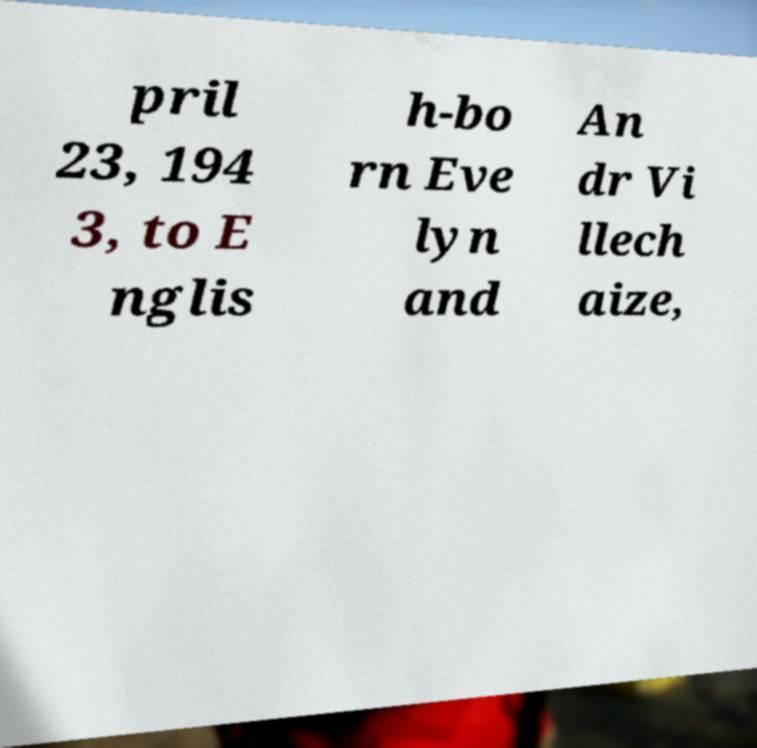Can you read and provide the text displayed in the image?This photo seems to have some interesting text. Can you extract and type it out for me? pril 23, 194 3, to E nglis h-bo rn Eve lyn and An dr Vi llech aize, 